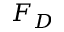Convert formula to latex. <formula><loc_0><loc_0><loc_500><loc_500>F _ { D }</formula> 